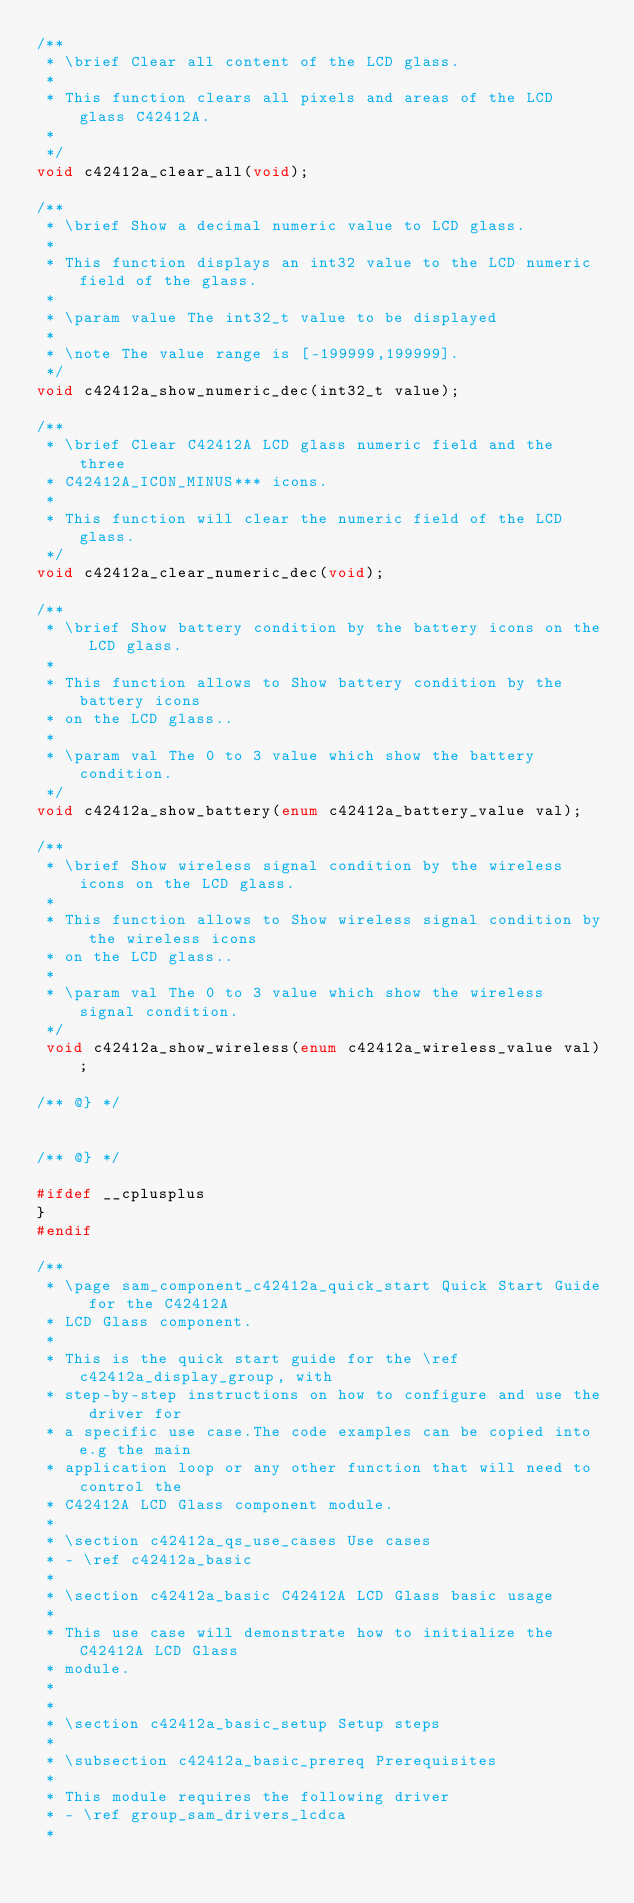<code> <loc_0><loc_0><loc_500><loc_500><_C_>/**
 * \brief Clear all content of the LCD glass.
 *
 * This function clears all pixels and areas of the LCD glass C42412A.
 *
 */
void c42412a_clear_all(void);

/**
 * \brief Show a decimal numeric value to LCD glass.
 *
 * This function displays an int32 value to the LCD numeric field of the glass.
 *
 * \param value The int32_t value to be displayed
 *
 * \note The value range is [-199999,199999].
 */
void c42412a_show_numeric_dec(int32_t value);

/**
 * \brief Clear C42412A LCD glass numeric field and the three
 * C42412A_ICON_MINUS*** icons.
 *
 * This function will clear the numeric field of the LCD glass.
 */
void c42412a_clear_numeric_dec(void);

/**
 * \brief Show battery condition by the battery icons on the LCD glass.
 *
 * This function allows to Show battery condition by the battery icons
 * on the LCD glass..
 *
 * \param val The 0 to 3 value which show the battery condition.
 */
void c42412a_show_battery(enum c42412a_battery_value val);

/**
 * \brief Show wireless signal condition by the wireless icons on the LCD glass.
 *
 * This function allows to Show wireless signal condition by the wireless icons
 * on the LCD glass..
 *
 * \param val The 0 to 3 value which show the wireless signal condition.
 */
 void c42412a_show_wireless(enum c42412a_wireless_value val);

/** @} */


/** @} */

#ifdef __cplusplus
}
#endif

/**
 * \page sam_component_c42412a_quick_start Quick Start Guide for the C42412A
 * LCD Glass component.
 *
 * This is the quick start guide for the \ref c42412a_display_group, with
 * step-by-step instructions on how to configure and use the driver for
 * a specific use case.The code examples can be copied into e.g the main
 * application loop or any other function that will need to control the
 * C42412A LCD Glass component module.
 *
 * \section c42412a_qs_use_cases Use cases
 * - \ref c42412a_basic
 *
 * \section c42412a_basic C42412A LCD Glass basic usage
 *
 * This use case will demonstrate how to initialize the C42412A LCD Glass
 * module.
 *
 *
 * \section c42412a_basic_setup Setup steps
 *
 * \subsection c42412a_basic_prereq Prerequisites
 *
 * This module requires the following driver
 * - \ref group_sam_drivers_lcdca
 *</code> 